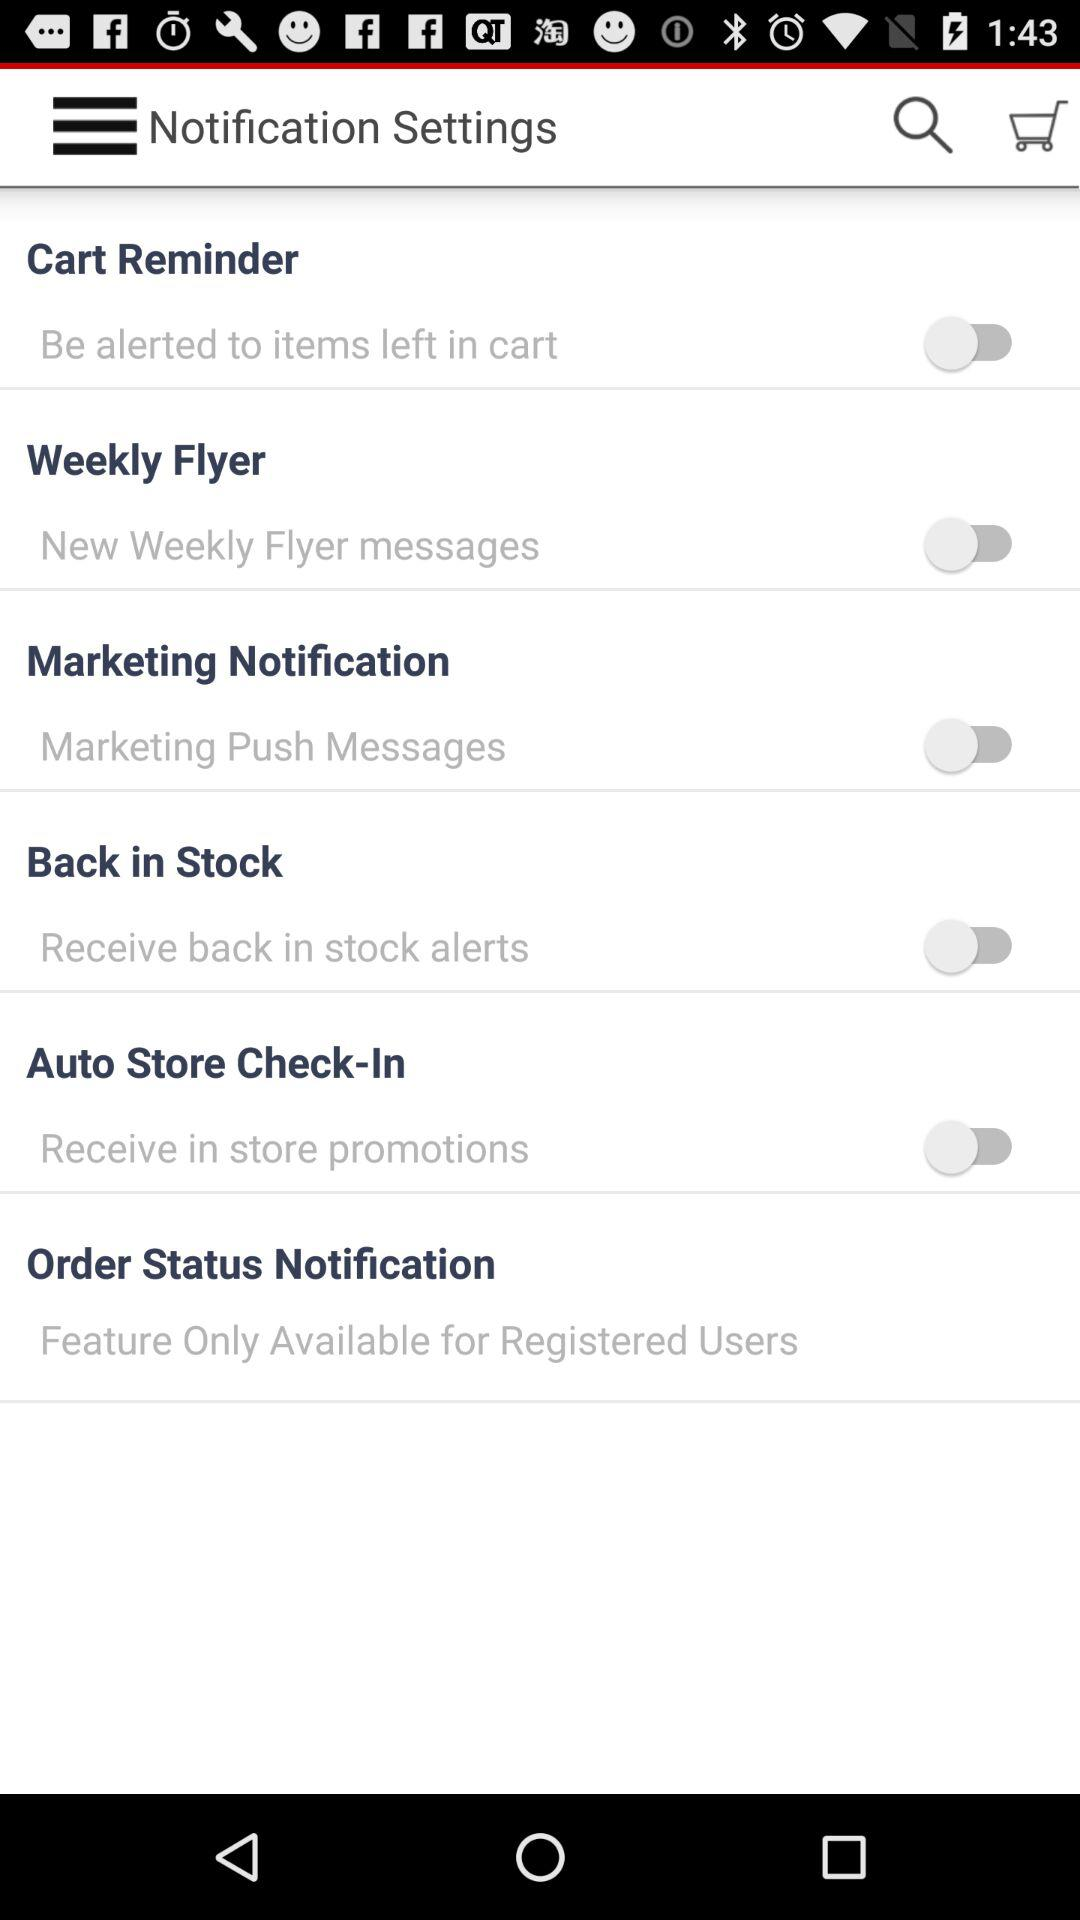What is the name of the application?
When the provided information is insufficient, respond with <no answer>. <no answer> 